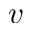Convert formula to latex. <formula><loc_0><loc_0><loc_500><loc_500>v</formula> 